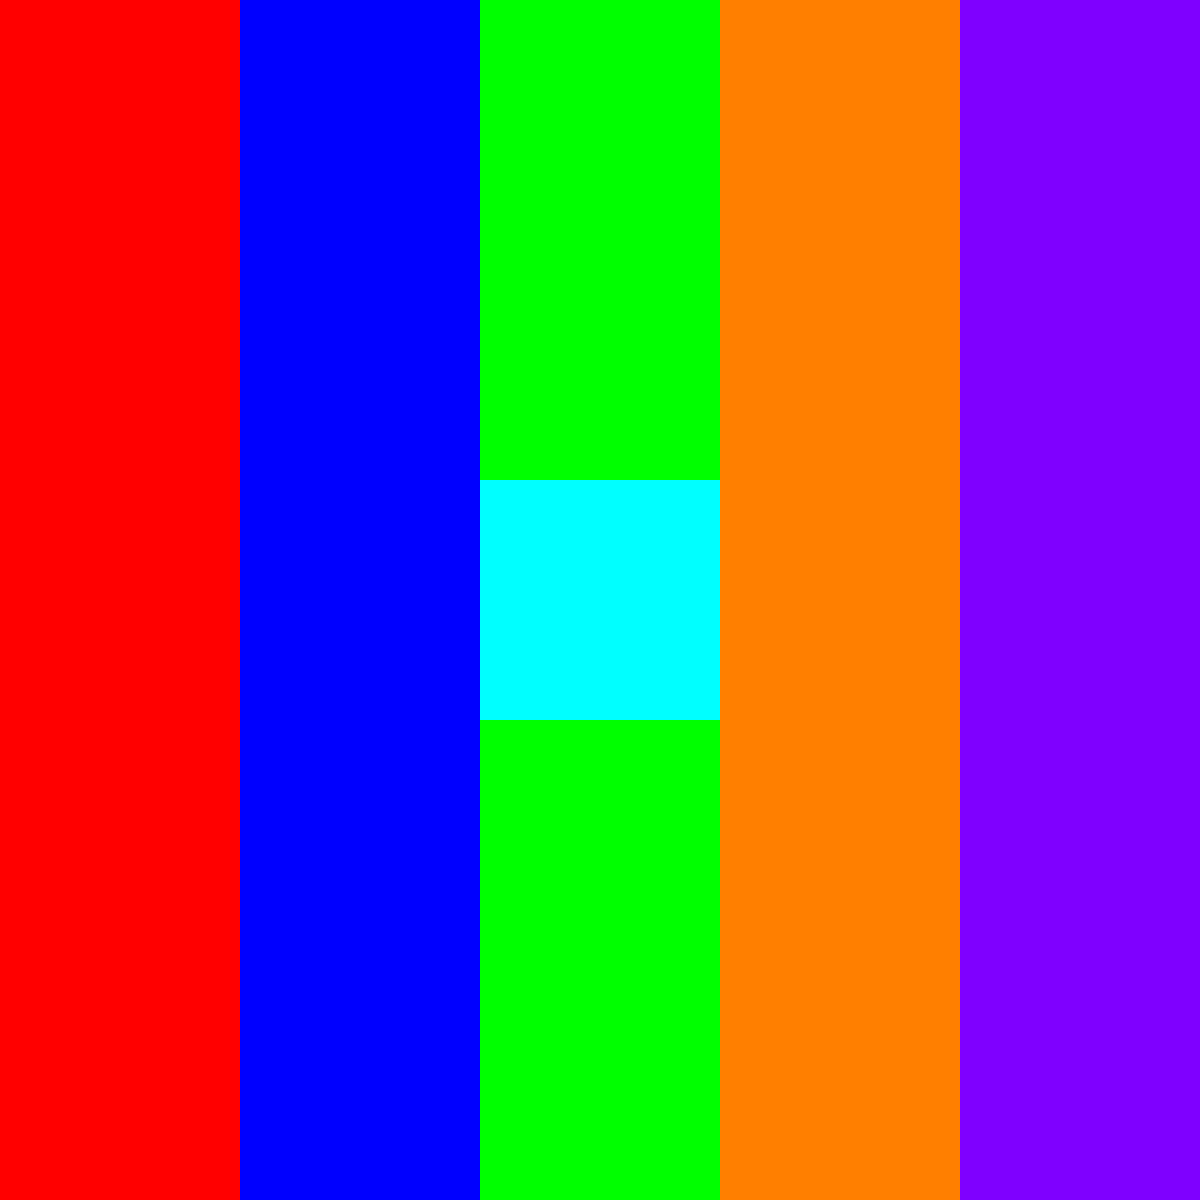Given a 5x5 grid of colored squares, where each row is uniformly colored except for one anomaly, identify the coordinates (row, column) of the anomalous square. The grid is indexed from (0,0) in the top-left corner to (4,4) in the bottom-right corner. To solve this problem, we'll analyze the image row by row:

1. Row 0 (top): All squares are red, no anomaly.
2. Row 1: All squares are blue, no anomaly.
3. Row 2: Four squares are green, but the middle square (column 2) is cyan. This is the anomaly.
4. Row 3: All squares are orange, no anomaly.
5. Row 4 (bottom): All squares are purple, no anomaly.

The anomaly is in row 2 (third row, index 2) and column 2 (middle column, index 2).

This type of analysis is crucial in computer vision and image processing, where detecting anomalies or inconsistencies in patterns can be used for various applications, such as quality control in manufacturing or identifying unusual events in surveillance footage.
Answer: (2,2) 